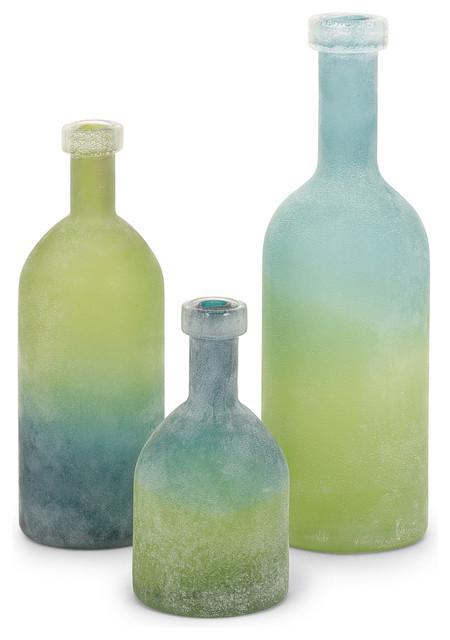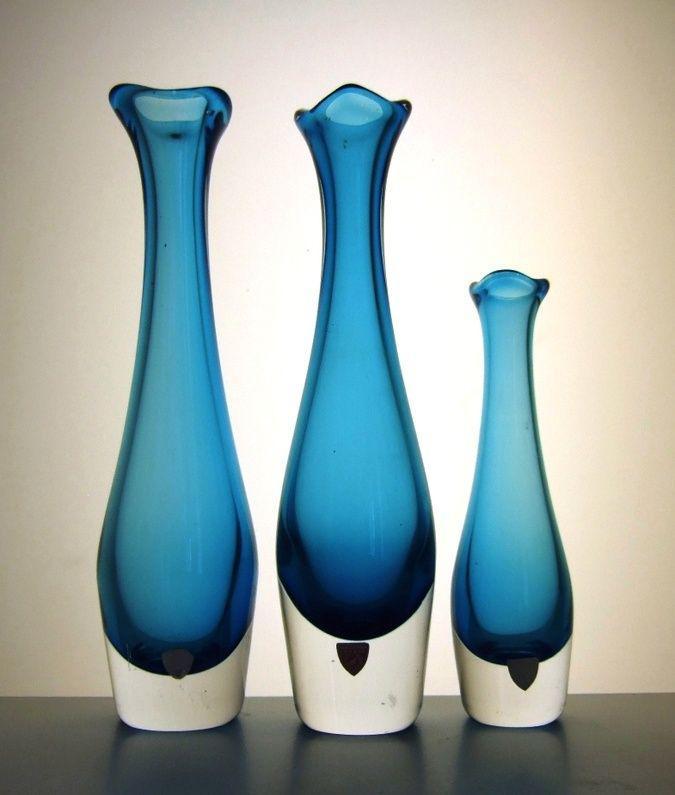The first image is the image on the left, the second image is the image on the right. For the images displayed, is the sentence "Bottles in the left image share the same shape." factually correct? Answer yes or no. Yes. 